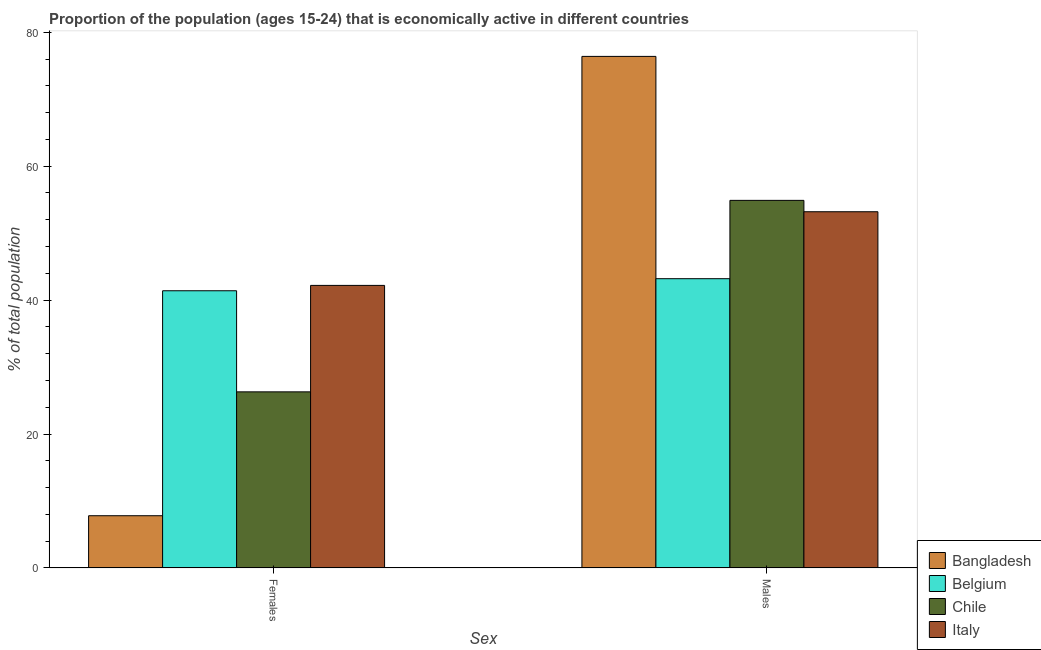Are the number of bars on each tick of the X-axis equal?
Ensure brevity in your answer.  Yes. How many bars are there on the 2nd tick from the left?
Provide a short and direct response. 4. What is the label of the 1st group of bars from the left?
Ensure brevity in your answer.  Females. What is the percentage of economically active male population in Italy?
Give a very brief answer. 53.2. Across all countries, what is the maximum percentage of economically active male population?
Your response must be concise. 76.4. Across all countries, what is the minimum percentage of economically active female population?
Make the answer very short. 7.8. What is the total percentage of economically active female population in the graph?
Give a very brief answer. 117.7. What is the difference between the percentage of economically active female population in Bangladesh and that in Italy?
Provide a short and direct response. -34.4. What is the difference between the percentage of economically active female population in Chile and the percentage of economically active male population in Bangladesh?
Your answer should be compact. -50.1. What is the average percentage of economically active male population per country?
Provide a short and direct response. 56.93. In how many countries, is the percentage of economically active female population greater than 68 %?
Your answer should be compact. 0. What is the ratio of the percentage of economically active female population in Belgium to that in Italy?
Provide a short and direct response. 0.98. Is the percentage of economically active female population in Belgium less than that in Chile?
Your answer should be compact. No. What does the 4th bar from the left in Males represents?
Your response must be concise. Italy. How many bars are there?
Your response must be concise. 8. Are the values on the major ticks of Y-axis written in scientific E-notation?
Offer a very short reply. No. Does the graph contain grids?
Ensure brevity in your answer.  No. How many legend labels are there?
Provide a short and direct response. 4. How are the legend labels stacked?
Ensure brevity in your answer.  Vertical. What is the title of the graph?
Your answer should be compact. Proportion of the population (ages 15-24) that is economically active in different countries. Does "Turkmenistan" appear as one of the legend labels in the graph?
Provide a succinct answer. No. What is the label or title of the X-axis?
Your answer should be very brief. Sex. What is the label or title of the Y-axis?
Keep it short and to the point. % of total population. What is the % of total population in Bangladesh in Females?
Provide a succinct answer. 7.8. What is the % of total population of Belgium in Females?
Offer a very short reply. 41.4. What is the % of total population of Chile in Females?
Make the answer very short. 26.3. What is the % of total population in Italy in Females?
Make the answer very short. 42.2. What is the % of total population of Bangladesh in Males?
Provide a short and direct response. 76.4. What is the % of total population in Belgium in Males?
Offer a terse response. 43.2. What is the % of total population of Chile in Males?
Ensure brevity in your answer.  54.9. What is the % of total population of Italy in Males?
Offer a very short reply. 53.2. Across all Sex, what is the maximum % of total population of Bangladesh?
Give a very brief answer. 76.4. Across all Sex, what is the maximum % of total population of Belgium?
Offer a terse response. 43.2. Across all Sex, what is the maximum % of total population in Chile?
Provide a short and direct response. 54.9. Across all Sex, what is the maximum % of total population in Italy?
Your answer should be compact. 53.2. Across all Sex, what is the minimum % of total population in Bangladesh?
Provide a succinct answer. 7.8. Across all Sex, what is the minimum % of total population of Belgium?
Provide a short and direct response. 41.4. Across all Sex, what is the minimum % of total population in Chile?
Make the answer very short. 26.3. Across all Sex, what is the minimum % of total population in Italy?
Provide a succinct answer. 42.2. What is the total % of total population of Bangladesh in the graph?
Make the answer very short. 84.2. What is the total % of total population of Belgium in the graph?
Your response must be concise. 84.6. What is the total % of total population in Chile in the graph?
Give a very brief answer. 81.2. What is the total % of total population in Italy in the graph?
Offer a very short reply. 95.4. What is the difference between the % of total population of Bangladesh in Females and that in Males?
Provide a succinct answer. -68.6. What is the difference between the % of total population in Belgium in Females and that in Males?
Provide a succinct answer. -1.8. What is the difference between the % of total population in Chile in Females and that in Males?
Ensure brevity in your answer.  -28.6. What is the difference between the % of total population in Italy in Females and that in Males?
Your answer should be compact. -11. What is the difference between the % of total population in Bangladesh in Females and the % of total population in Belgium in Males?
Your answer should be very brief. -35.4. What is the difference between the % of total population in Bangladesh in Females and the % of total population in Chile in Males?
Your response must be concise. -47.1. What is the difference between the % of total population of Bangladesh in Females and the % of total population of Italy in Males?
Ensure brevity in your answer.  -45.4. What is the difference between the % of total population of Belgium in Females and the % of total population of Chile in Males?
Provide a succinct answer. -13.5. What is the difference between the % of total population of Belgium in Females and the % of total population of Italy in Males?
Keep it short and to the point. -11.8. What is the difference between the % of total population of Chile in Females and the % of total population of Italy in Males?
Your response must be concise. -26.9. What is the average % of total population in Bangladesh per Sex?
Offer a terse response. 42.1. What is the average % of total population in Belgium per Sex?
Offer a very short reply. 42.3. What is the average % of total population of Chile per Sex?
Ensure brevity in your answer.  40.6. What is the average % of total population of Italy per Sex?
Provide a succinct answer. 47.7. What is the difference between the % of total population of Bangladesh and % of total population of Belgium in Females?
Give a very brief answer. -33.6. What is the difference between the % of total population in Bangladesh and % of total population in Chile in Females?
Your answer should be compact. -18.5. What is the difference between the % of total population of Bangladesh and % of total population of Italy in Females?
Your response must be concise. -34.4. What is the difference between the % of total population in Belgium and % of total population in Chile in Females?
Ensure brevity in your answer.  15.1. What is the difference between the % of total population in Chile and % of total population in Italy in Females?
Keep it short and to the point. -15.9. What is the difference between the % of total population in Bangladesh and % of total population in Belgium in Males?
Offer a terse response. 33.2. What is the difference between the % of total population in Bangladesh and % of total population in Chile in Males?
Make the answer very short. 21.5. What is the difference between the % of total population in Bangladesh and % of total population in Italy in Males?
Your answer should be compact. 23.2. What is the difference between the % of total population in Chile and % of total population in Italy in Males?
Provide a short and direct response. 1.7. What is the ratio of the % of total population of Bangladesh in Females to that in Males?
Your answer should be compact. 0.1. What is the ratio of the % of total population of Belgium in Females to that in Males?
Give a very brief answer. 0.96. What is the ratio of the % of total population in Chile in Females to that in Males?
Provide a succinct answer. 0.48. What is the ratio of the % of total population in Italy in Females to that in Males?
Make the answer very short. 0.79. What is the difference between the highest and the second highest % of total population in Bangladesh?
Keep it short and to the point. 68.6. What is the difference between the highest and the second highest % of total population in Chile?
Make the answer very short. 28.6. What is the difference between the highest and the second highest % of total population of Italy?
Make the answer very short. 11. What is the difference between the highest and the lowest % of total population of Bangladesh?
Offer a very short reply. 68.6. What is the difference between the highest and the lowest % of total population of Chile?
Provide a succinct answer. 28.6. What is the difference between the highest and the lowest % of total population of Italy?
Your answer should be compact. 11. 